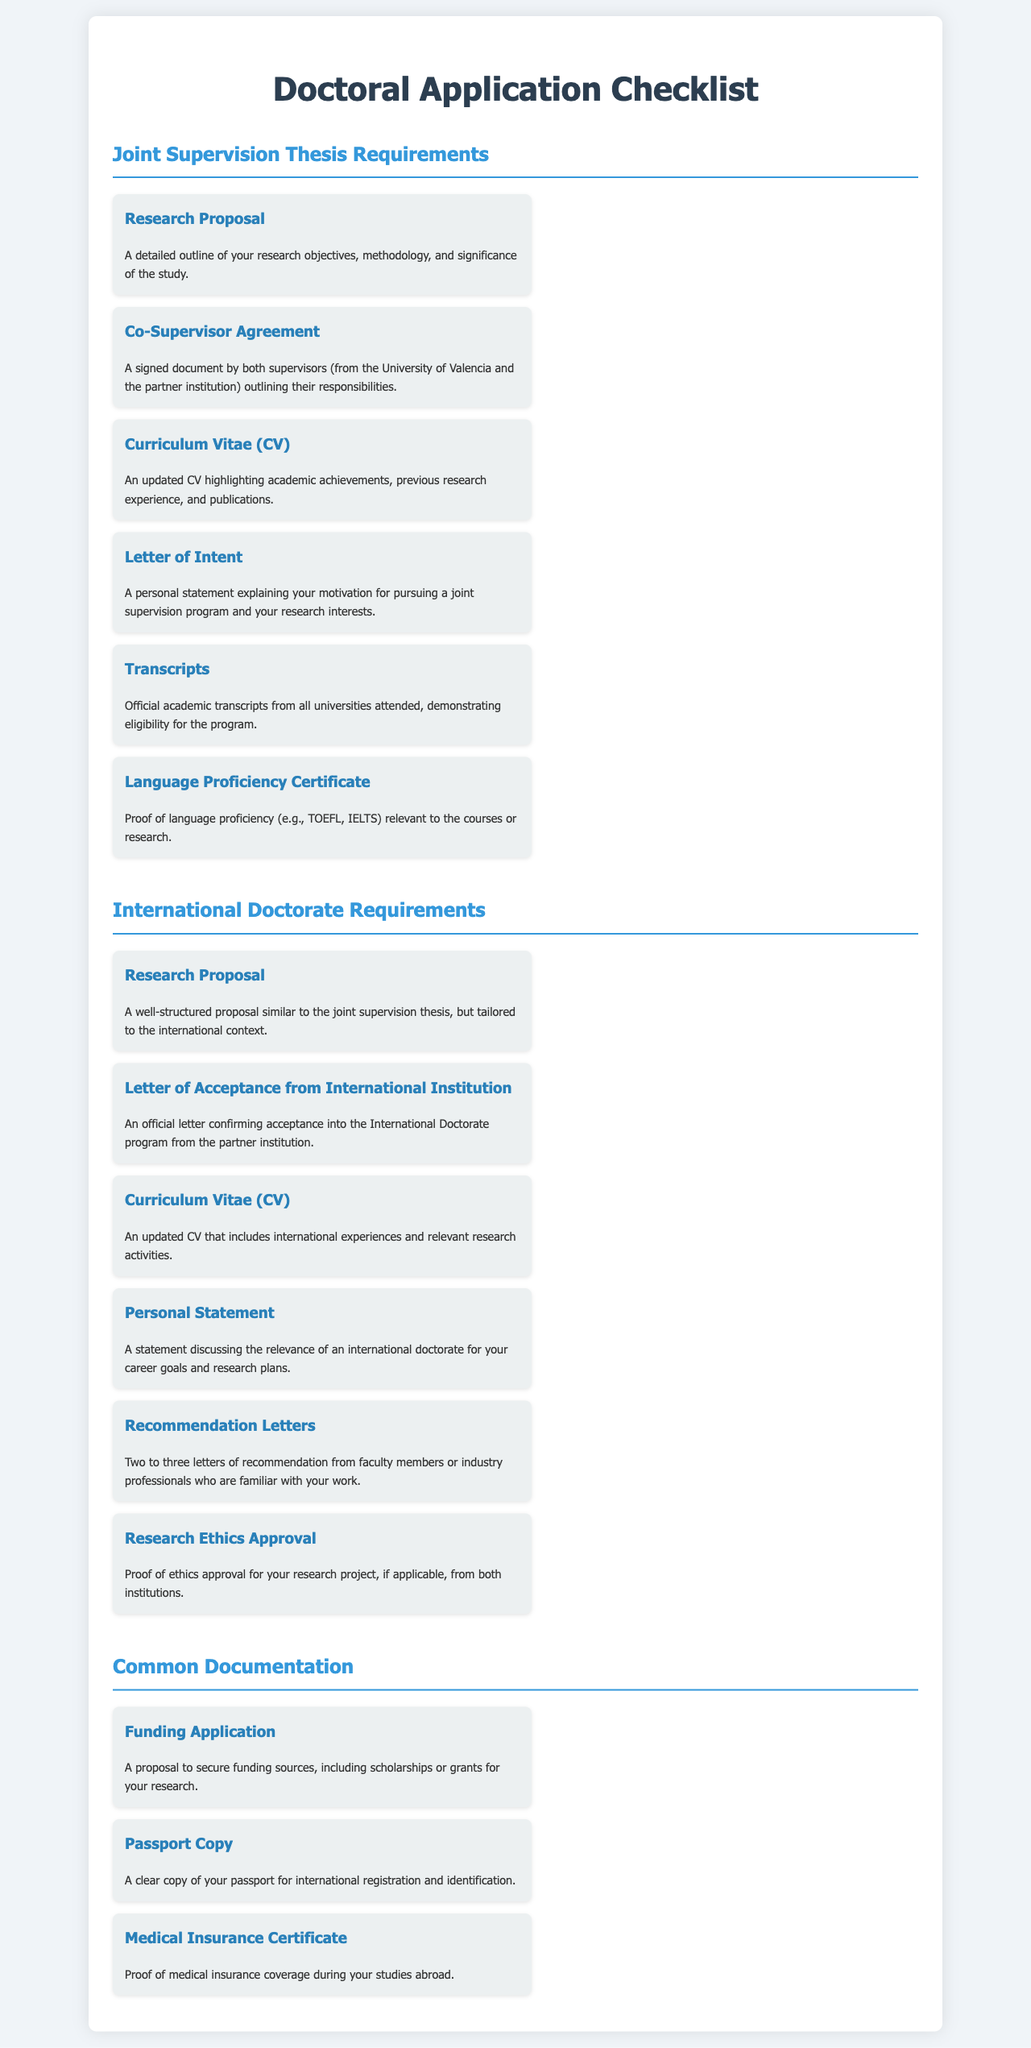What documentation is required for a Joint Supervision Thesis? The checklist lists specific documents needed for a Joint Supervision Thesis, which include research proposal, co-supervisor agreement, CV, letter of intent, transcripts, and language proficiency certificate.
Answer: Research Proposal, Co-Supervisor Agreement, CV, Letter of Intent, Transcripts, Language Proficiency Certificate How many recommendation letters are needed for the International Doctorate? The document specifies that you need two to three letters of recommendation for the International Doctorate application.
Answer: Two to three What is one requirement that is common to both programs? The document indicates that both the Joint Supervision Thesis and International Doctorate require a funding application.
Answer: Funding Application What document confirms acceptance into the International Doctorate program? The document states that a letter of acceptance from the international institution is required.
Answer: Letter of Acceptance from International Institution What is required in the Research Proposal for the International Doctorate? The document specifies that the research proposal should be well-structured and tailored to the international context.
Answer: Tailored to the international context What personal document must be included for international registration? The checklist requires a clear copy of your passport for international registration and identification.
Answer: Passport Copy What is necessary to prove language proficiency for the Joint Supervision Thesis? The document lists a language proficiency certificate as proof of language competence.
Answer: Language Proficiency Certificate Which document outlines the responsibilities of the supervisors? The document mentions the co-supervisor agreement, which outlines their responsibilities.
Answer: Co-Supervisor Agreement What is the purpose of the personal statement for the International Doctorate? The document indicates that the personal statement should discuss the relevance of an international doctorate for your career goals and research plans.
Answer: Relevance of an international doctorate for career goals 